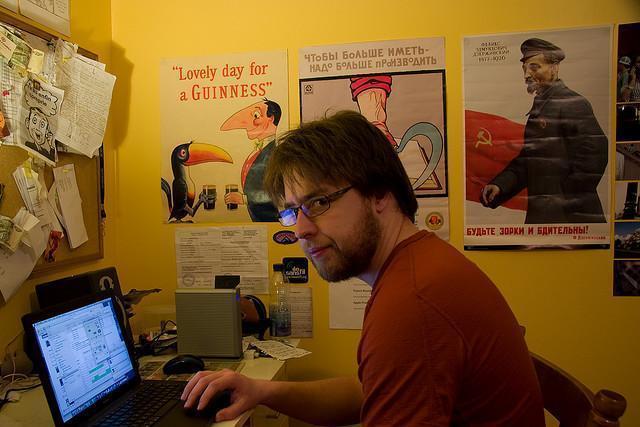What are the toucan and the man going to enjoy?
Choose the right answer from the provided options to respond to the question.
Options: Soda, beer, some wine, some water. Beer. 